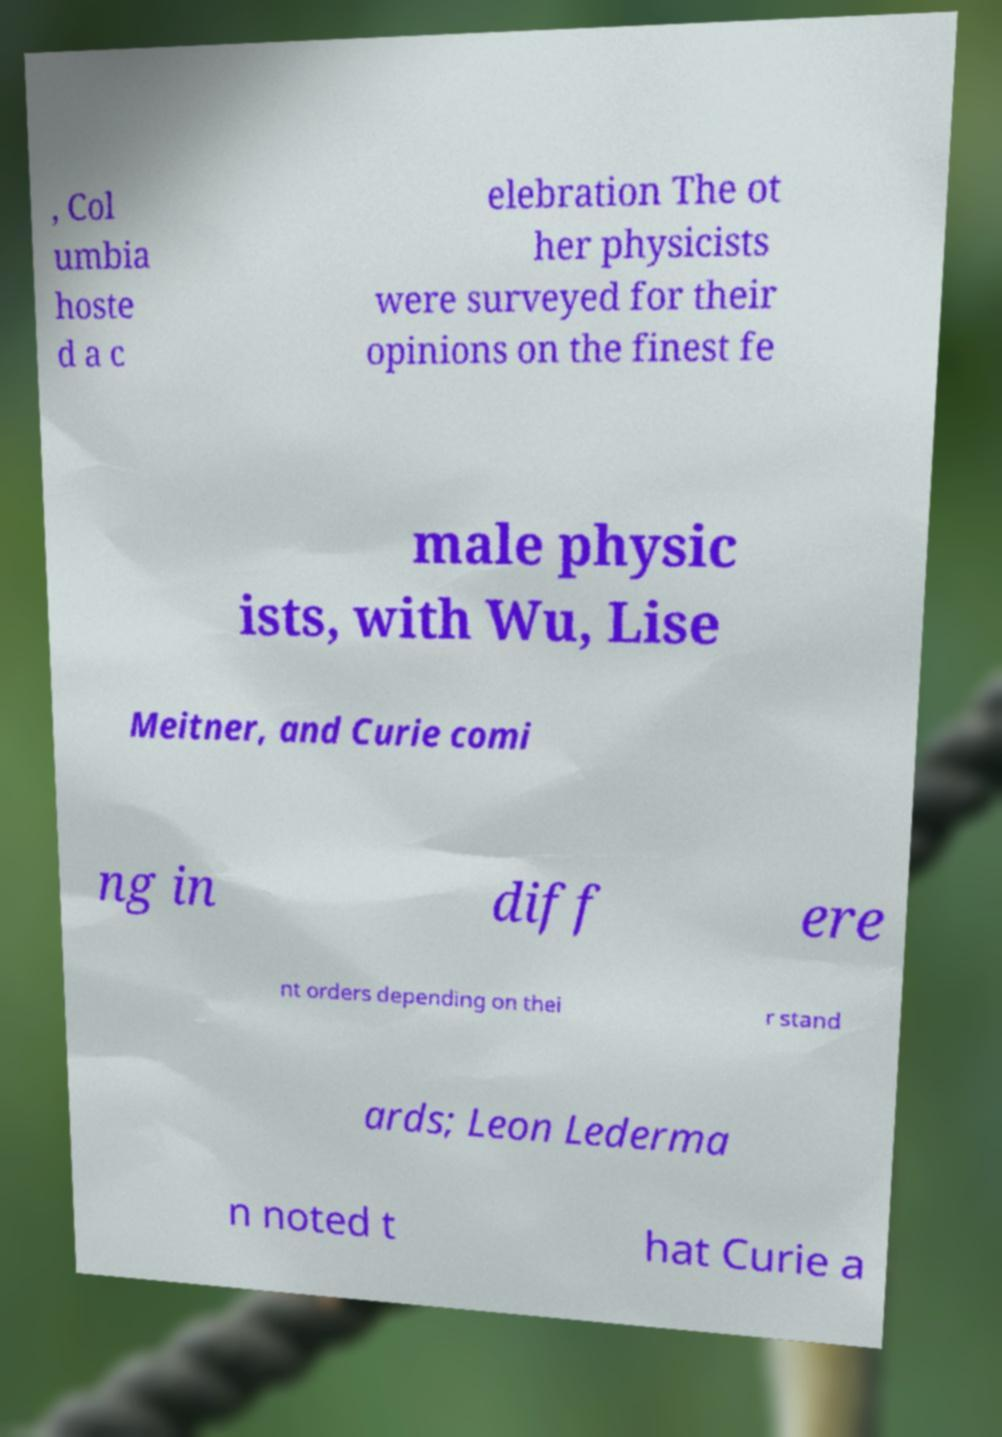What messages or text are displayed in this image? I need them in a readable, typed format. , Col umbia hoste d a c elebration The ot her physicists were surveyed for their opinions on the finest fe male physic ists, with Wu, Lise Meitner, and Curie comi ng in diff ere nt orders depending on thei r stand ards; Leon Lederma n noted t hat Curie a 